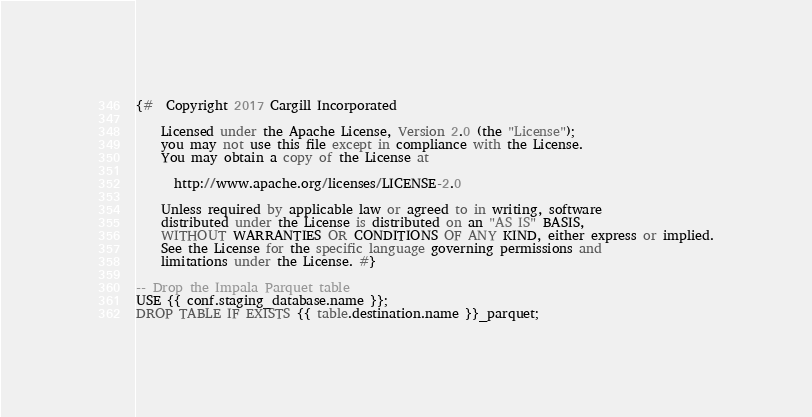Convert code to text. <code><loc_0><loc_0><loc_500><loc_500><_SQL_>{#  Copyright 2017 Cargill Incorporated

    Licensed under the Apache License, Version 2.0 (the "License");
    you may not use this file except in compliance with the License.
    You may obtain a copy of the License at

      http://www.apache.org/licenses/LICENSE-2.0

    Unless required by applicable law or agreed to in writing, software
    distributed under the License is distributed on an "AS IS" BASIS,
    WITHOUT WARRANTIES OR CONDITIONS OF ANY KIND, either express or implied.
    See the License for the specific language governing permissions and
    limitations under the License. #}

-- Drop the Impala Parquet table
USE {{ conf.staging_database.name }};
DROP TABLE IF EXISTS {{ table.destination.name }}_parquet;
</code> 